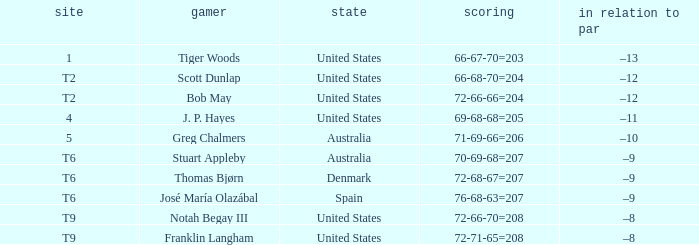What is the place of the player with a 66-68-70=204 score? T2. 